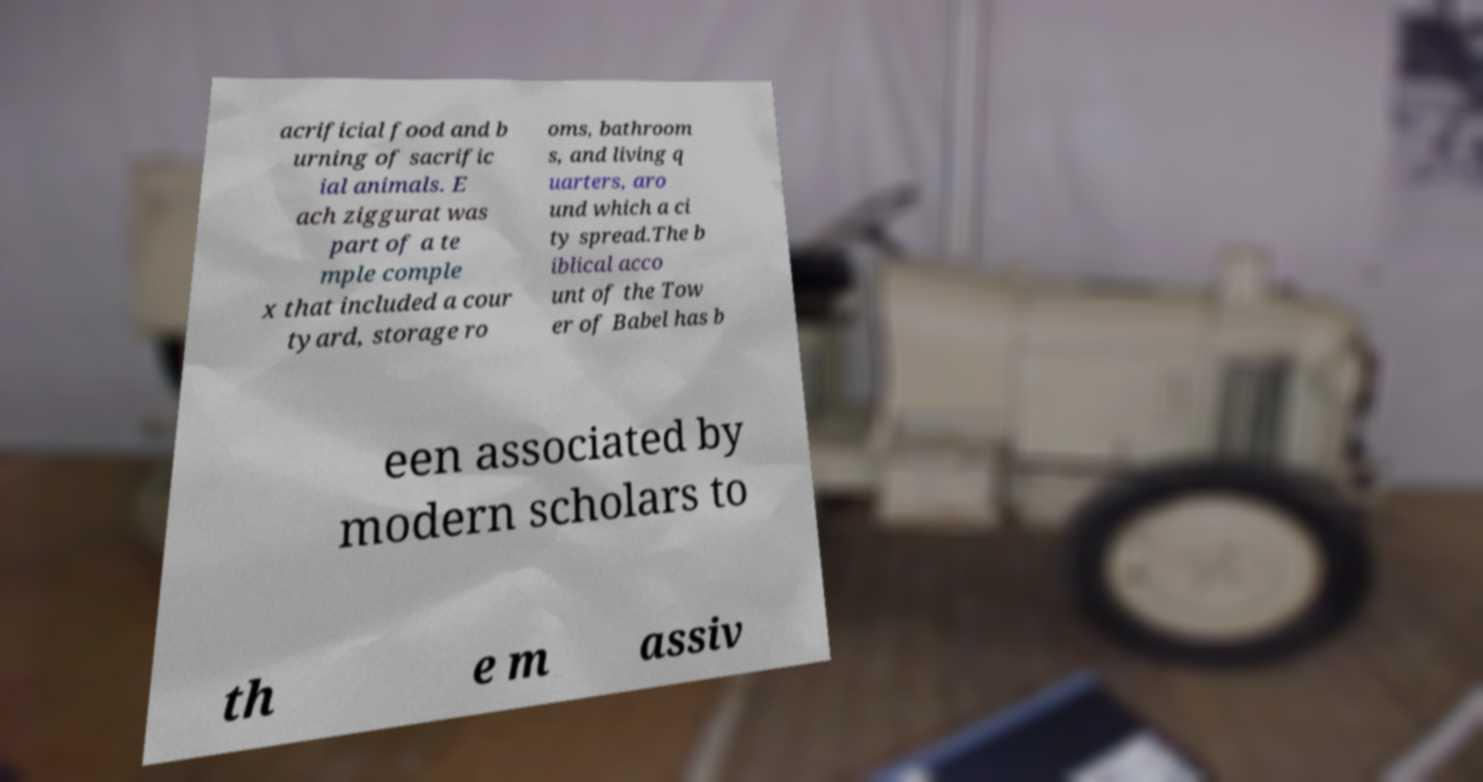There's text embedded in this image that I need extracted. Can you transcribe it verbatim? acrificial food and b urning of sacrific ial animals. E ach ziggurat was part of a te mple comple x that included a cour tyard, storage ro oms, bathroom s, and living q uarters, aro und which a ci ty spread.The b iblical acco unt of the Tow er of Babel has b een associated by modern scholars to th e m assiv 